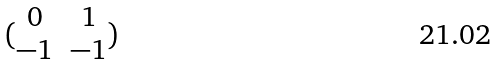Convert formula to latex. <formula><loc_0><loc_0><loc_500><loc_500>( \begin{matrix} 0 & 1 \\ - 1 & - 1 \end{matrix} )</formula> 